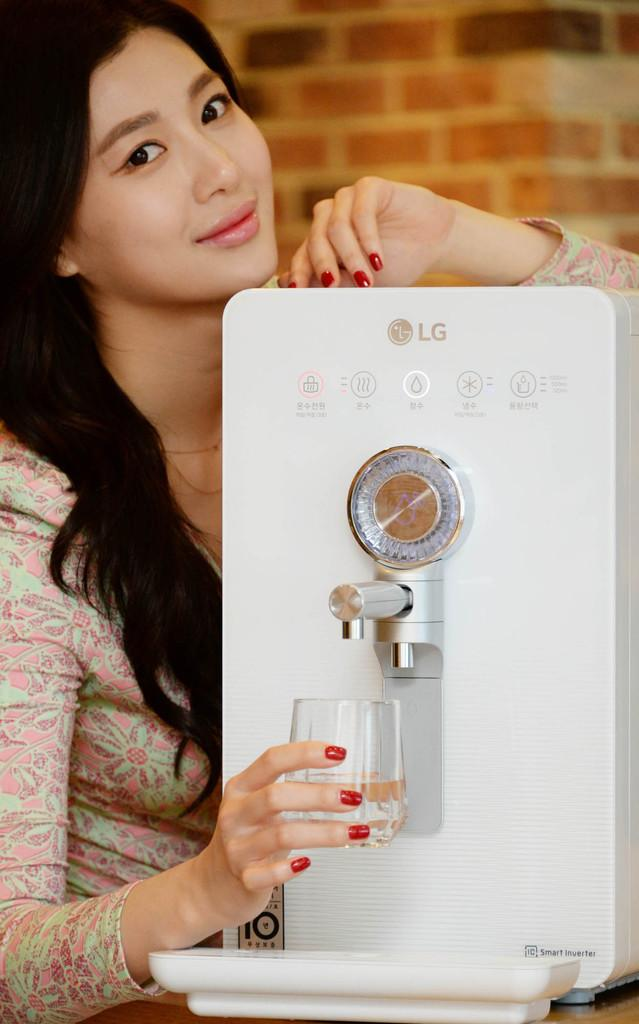What object is the main focus of the image? There is a water purifier in the image. Where is the water purifier located? The water purifier is on a surface. Who is present in the image? There is a woman in the image. What is the woman doing with her hand? The woman is holding a glass with her hand. What is the woman's facial expression? The woman is smiling. What can be seen in the background of the image? There is a wall in the background of the image. What type of toothbrush is the woman using in the image? There is no toothbrush present in the image. What opinion does the woman have about the water purifier in the image? The image does not provide any information about the woman's opinion on the water purifier. 